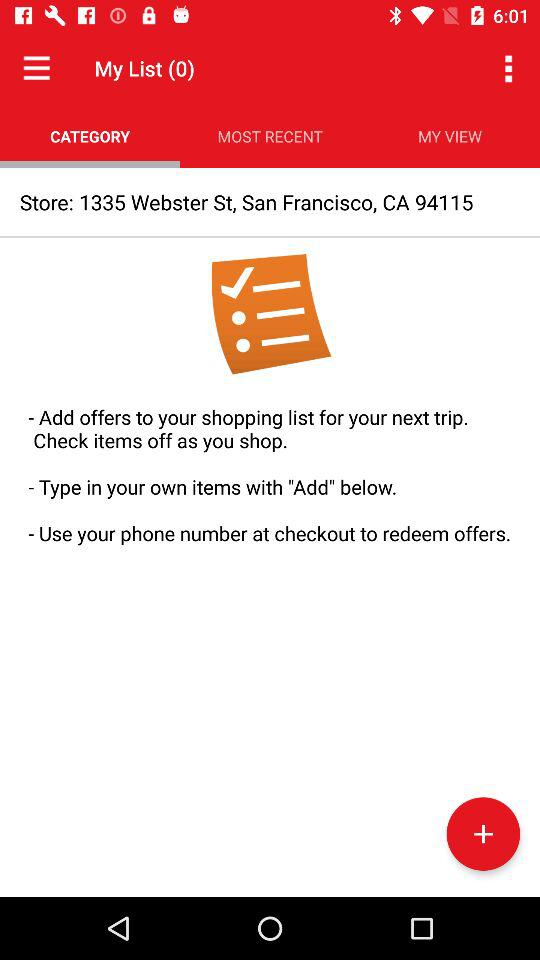What's the total number of items in "My List"? The total number of items is 0. 